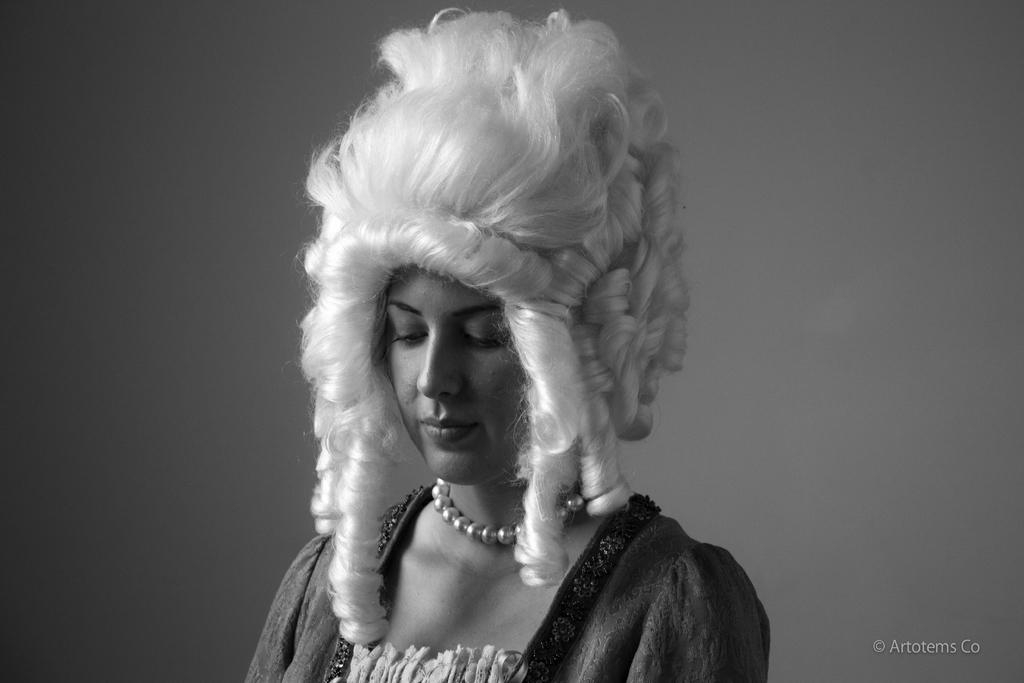What is the appearance of the woman's hair in the image? The woman in the image has white hair. What is the woman doing in the image? The woman is standing. What can be seen in the background of the image? There is a wall in the background of the image. Where is the text located in the image? The text is at the bottom right of the image. What type of toothbrush is the woman using to brush her eyes in the image? There is no toothbrush or brushing of eyes depicted in the image. 